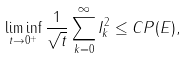<formula> <loc_0><loc_0><loc_500><loc_500>\liminf _ { t \to 0 ^ { + } } \frac { 1 } { \sqrt { t } } \sum _ { k = 0 } ^ { \infty } I _ { k } ^ { 2 } \leq C P ( E ) ,</formula> 